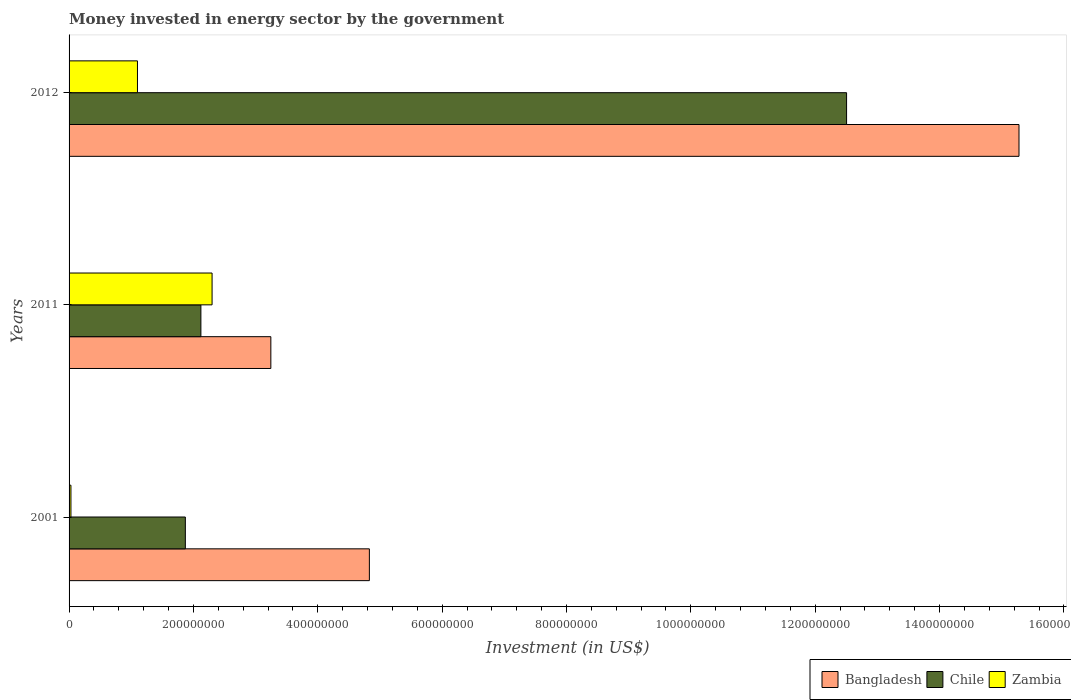How many different coloured bars are there?
Provide a succinct answer. 3. How many groups of bars are there?
Make the answer very short. 3. What is the label of the 1st group of bars from the top?
Make the answer very short. 2012. In how many cases, is the number of bars for a given year not equal to the number of legend labels?
Offer a terse response. 0. What is the money spent in energy sector in Zambia in 2001?
Your answer should be very brief. 3.00e+06. Across all years, what is the maximum money spent in energy sector in Zambia?
Your answer should be very brief. 2.30e+08. Across all years, what is the minimum money spent in energy sector in Bangladesh?
Provide a short and direct response. 3.25e+08. In which year was the money spent in energy sector in Zambia minimum?
Provide a succinct answer. 2001. What is the total money spent in energy sector in Chile in the graph?
Provide a succinct answer. 1.65e+09. What is the difference between the money spent in energy sector in Zambia in 2001 and that in 2011?
Provide a succinct answer. -2.27e+08. What is the difference between the money spent in energy sector in Bangladesh in 2011 and the money spent in energy sector in Chile in 2012?
Ensure brevity in your answer.  -9.26e+08. What is the average money spent in energy sector in Bangladesh per year?
Your answer should be compact. 7.78e+08. In the year 2012, what is the difference between the money spent in energy sector in Bangladesh and money spent in energy sector in Zambia?
Ensure brevity in your answer.  1.42e+09. In how many years, is the money spent in energy sector in Zambia greater than 1520000000 US$?
Your answer should be compact. 0. What is the ratio of the money spent in energy sector in Zambia in 2001 to that in 2011?
Make the answer very short. 0.01. Is the money spent in energy sector in Chile in 2001 less than that in 2011?
Keep it short and to the point. Yes. Is the difference between the money spent in energy sector in Bangladesh in 2001 and 2012 greater than the difference between the money spent in energy sector in Zambia in 2001 and 2012?
Offer a very short reply. No. What is the difference between the highest and the second highest money spent in energy sector in Bangladesh?
Provide a succinct answer. 1.04e+09. What is the difference between the highest and the lowest money spent in energy sector in Bangladesh?
Your answer should be very brief. 1.20e+09. Is the sum of the money spent in energy sector in Bangladesh in 2001 and 2011 greater than the maximum money spent in energy sector in Chile across all years?
Your answer should be compact. No. What does the 3rd bar from the top in 2001 represents?
Your answer should be very brief. Bangladesh. What does the 1st bar from the bottom in 2012 represents?
Make the answer very short. Bangladesh. Is it the case that in every year, the sum of the money spent in energy sector in Bangladesh and money spent in energy sector in Zambia is greater than the money spent in energy sector in Chile?
Your response must be concise. Yes. How many bars are there?
Your response must be concise. 9. How many years are there in the graph?
Your response must be concise. 3. How are the legend labels stacked?
Your response must be concise. Horizontal. What is the title of the graph?
Offer a terse response. Money invested in energy sector by the government. What is the label or title of the X-axis?
Provide a succinct answer. Investment (in US$). What is the label or title of the Y-axis?
Give a very brief answer. Years. What is the Investment (in US$) of Bangladesh in 2001?
Keep it short and to the point. 4.83e+08. What is the Investment (in US$) in Chile in 2001?
Provide a succinct answer. 1.87e+08. What is the Investment (in US$) in Zambia in 2001?
Your response must be concise. 3.00e+06. What is the Investment (in US$) in Bangladesh in 2011?
Give a very brief answer. 3.25e+08. What is the Investment (in US$) of Chile in 2011?
Your answer should be compact. 2.12e+08. What is the Investment (in US$) in Zambia in 2011?
Your response must be concise. 2.30e+08. What is the Investment (in US$) in Bangladesh in 2012?
Give a very brief answer. 1.53e+09. What is the Investment (in US$) in Chile in 2012?
Offer a terse response. 1.25e+09. What is the Investment (in US$) of Zambia in 2012?
Your answer should be compact. 1.10e+08. Across all years, what is the maximum Investment (in US$) in Bangladesh?
Your answer should be compact. 1.53e+09. Across all years, what is the maximum Investment (in US$) of Chile?
Your response must be concise. 1.25e+09. Across all years, what is the maximum Investment (in US$) of Zambia?
Ensure brevity in your answer.  2.30e+08. Across all years, what is the minimum Investment (in US$) in Bangladesh?
Keep it short and to the point. 3.25e+08. Across all years, what is the minimum Investment (in US$) in Chile?
Your answer should be compact. 1.87e+08. Across all years, what is the minimum Investment (in US$) in Zambia?
Give a very brief answer. 3.00e+06. What is the total Investment (in US$) of Bangladesh in the graph?
Provide a succinct answer. 2.34e+09. What is the total Investment (in US$) of Chile in the graph?
Make the answer very short. 1.65e+09. What is the total Investment (in US$) of Zambia in the graph?
Provide a short and direct response. 3.43e+08. What is the difference between the Investment (in US$) in Bangladesh in 2001 and that in 2011?
Ensure brevity in your answer.  1.58e+08. What is the difference between the Investment (in US$) in Chile in 2001 and that in 2011?
Ensure brevity in your answer.  -2.50e+07. What is the difference between the Investment (in US$) in Zambia in 2001 and that in 2011?
Keep it short and to the point. -2.27e+08. What is the difference between the Investment (in US$) of Bangladesh in 2001 and that in 2012?
Provide a short and direct response. -1.04e+09. What is the difference between the Investment (in US$) in Chile in 2001 and that in 2012?
Your answer should be compact. -1.06e+09. What is the difference between the Investment (in US$) of Zambia in 2001 and that in 2012?
Give a very brief answer. -1.07e+08. What is the difference between the Investment (in US$) of Bangladesh in 2011 and that in 2012?
Your response must be concise. -1.20e+09. What is the difference between the Investment (in US$) in Chile in 2011 and that in 2012?
Your answer should be very brief. -1.04e+09. What is the difference between the Investment (in US$) in Zambia in 2011 and that in 2012?
Your response must be concise. 1.20e+08. What is the difference between the Investment (in US$) of Bangladesh in 2001 and the Investment (in US$) of Chile in 2011?
Keep it short and to the point. 2.71e+08. What is the difference between the Investment (in US$) of Bangladesh in 2001 and the Investment (in US$) of Zambia in 2011?
Your answer should be very brief. 2.53e+08. What is the difference between the Investment (in US$) of Chile in 2001 and the Investment (in US$) of Zambia in 2011?
Give a very brief answer. -4.30e+07. What is the difference between the Investment (in US$) in Bangladesh in 2001 and the Investment (in US$) in Chile in 2012?
Offer a very short reply. -7.68e+08. What is the difference between the Investment (in US$) of Bangladesh in 2001 and the Investment (in US$) of Zambia in 2012?
Provide a short and direct response. 3.73e+08. What is the difference between the Investment (in US$) in Chile in 2001 and the Investment (in US$) in Zambia in 2012?
Make the answer very short. 7.70e+07. What is the difference between the Investment (in US$) of Bangladesh in 2011 and the Investment (in US$) of Chile in 2012?
Offer a terse response. -9.26e+08. What is the difference between the Investment (in US$) in Bangladesh in 2011 and the Investment (in US$) in Zambia in 2012?
Your answer should be very brief. 2.15e+08. What is the difference between the Investment (in US$) in Chile in 2011 and the Investment (in US$) in Zambia in 2012?
Give a very brief answer. 1.02e+08. What is the average Investment (in US$) of Bangladesh per year?
Your response must be concise. 7.78e+08. What is the average Investment (in US$) in Chile per year?
Provide a succinct answer. 5.50e+08. What is the average Investment (in US$) in Zambia per year?
Provide a short and direct response. 1.14e+08. In the year 2001, what is the difference between the Investment (in US$) in Bangladesh and Investment (in US$) in Chile?
Make the answer very short. 2.96e+08. In the year 2001, what is the difference between the Investment (in US$) in Bangladesh and Investment (in US$) in Zambia?
Provide a short and direct response. 4.80e+08. In the year 2001, what is the difference between the Investment (in US$) of Chile and Investment (in US$) of Zambia?
Keep it short and to the point. 1.84e+08. In the year 2011, what is the difference between the Investment (in US$) of Bangladesh and Investment (in US$) of Chile?
Keep it short and to the point. 1.13e+08. In the year 2011, what is the difference between the Investment (in US$) in Bangladesh and Investment (in US$) in Zambia?
Your answer should be very brief. 9.45e+07. In the year 2011, what is the difference between the Investment (in US$) of Chile and Investment (in US$) of Zambia?
Ensure brevity in your answer.  -1.80e+07. In the year 2012, what is the difference between the Investment (in US$) of Bangladesh and Investment (in US$) of Chile?
Give a very brief answer. 2.77e+08. In the year 2012, what is the difference between the Investment (in US$) in Bangladesh and Investment (in US$) in Zambia?
Your answer should be compact. 1.42e+09. In the year 2012, what is the difference between the Investment (in US$) of Chile and Investment (in US$) of Zambia?
Provide a short and direct response. 1.14e+09. What is the ratio of the Investment (in US$) in Bangladesh in 2001 to that in 2011?
Your answer should be compact. 1.49. What is the ratio of the Investment (in US$) of Chile in 2001 to that in 2011?
Provide a succinct answer. 0.88. What is the ratio of the Investment (in US$) in Zambia in 2001 to that in 2011?
Your response must be concise. 0.01. What is the ratio of the Investment (in US$) in Bangladesh in 2001 to that in 2012?
Your answer should be very brief. 0.32. What is the ratio of the Investment (in US$) in Chile in 2001 to that in 2012?
Keep it short and to the point. 0.15. What is the ratio of the Investment (in US$) in Zambia in 2001 to that in 2012?
Your answer should be compact. 0.03. What is the ratio of the Investment (in US$) of Bangladesh in 2011 to that in 2012?
Offer a very short reply. 0.21. What is the ratio of the Investment (in US$) in Chile in 2011 to that in 2012?
Offer a terse response. 0.17. What is the ratio of the Investment (in US$) in Zambia in 2011 to that in 2012?
Give a very brief answer. 2.09. What is the difference between the highest and the second highest Investment (in US$) of Bangladesh?
Ensure brevity in your answer.  1.04e+09. What is the difference between the highest and the second highest Investment (in US$) in Chile?
Your answer should be compact. 1.04e+09. What is the difference between the highest and the second highest Investment (in US$) in Zambia?
Make the answer very short. 1.20e+08. What is the difference between the highest and the lowest Investment (in US$) in Bangladesh?
Your answer should be compact. 1.20e+09. What is the difference between the highest and the lowest Investment (in US$) of Chile?
Your answer should be compact. 1.06e+09. What is the difference between the highest and the lowest Investment (in US$) in Zambia?
Ensure brevity in your answer.  2.27e+08. 